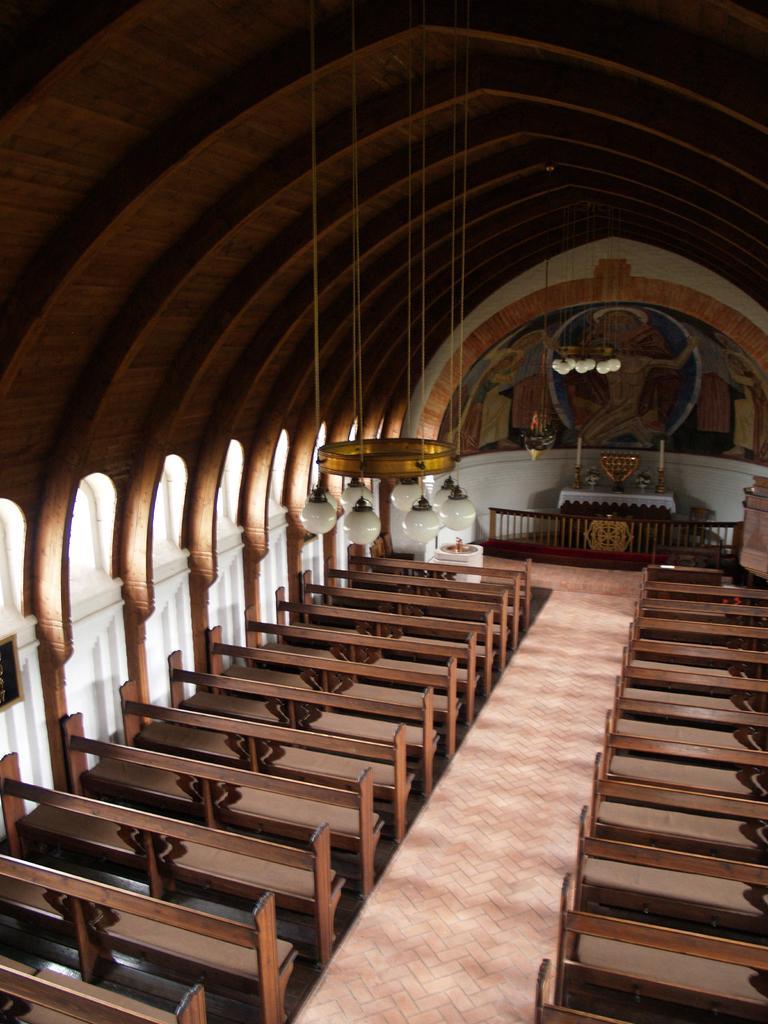How would you summarize this image in a sentence or two? In this image I can see the aisle, few benches on both sides of the aisle, the ceiling, few chandeliers, the railing, a table and some painting on the wall. 